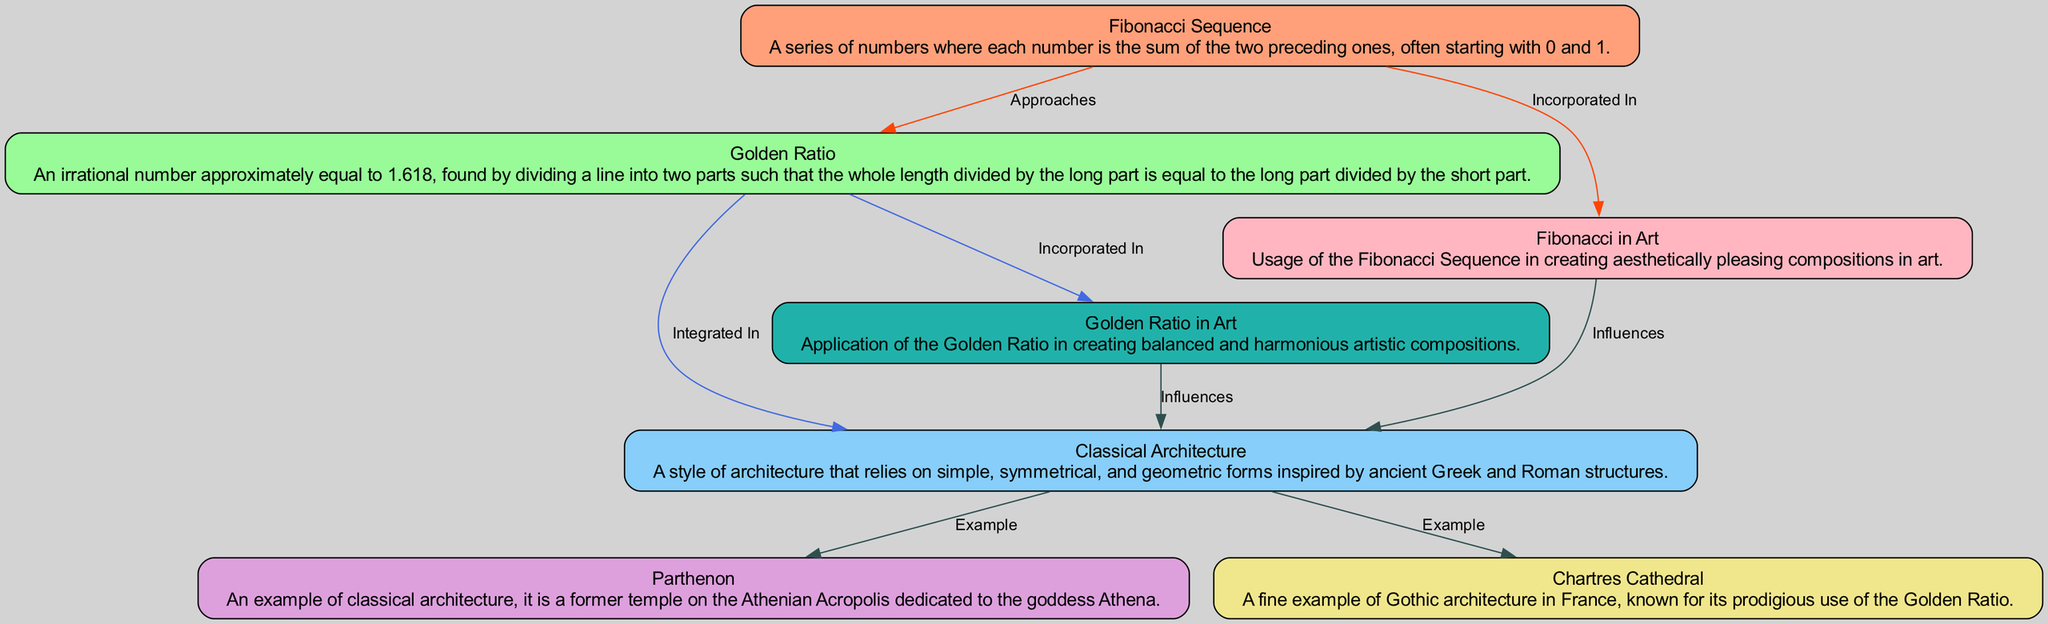What are the examples of Classical Architecture in the diagram? The diagram includes two examples of Classical Architecture: the Parthenon and Chartres Cathedral, which are highlighted as examples connecting to the Classical Architecture node.
Answer: Parthenon, Chartres Cathedral What relationship exists between the Fibonacci Sequence and the Golden Ratio? The diagram shows a directed edge labeled "Approaches" leading from the Fibonacci Sequence node to the Golden Ratio node, indicating their connection.
Answer: Approaches How many nodes are represented in the diagram? By counting the nodes listed, we can determine that there are seven unique nodes in this diagram related to Fibonacci, the Golden Ratio, and architecture.
Answer: 7 What influences the Fibonacci Sequence in this diagram? There is a directed edge labeled "Influences" connecting the Fibonacci in Art node to the Classical Architecture node, illustrating that the Fibonacci Sequence influences Classical Architecture through its application in art.
Answer: Classical Architecture What is the approximate value of the Golden Ratio? The description in the Golden Ratio node states that it is an irrational number approximately equal to 1.618, which is a key quantitative detail.
Answer: 1.618 How does the Golden Ratio relate specifically to Art in the diagram? The diagram shows a directed edge labeled "Incorporated In" leading from the Golden Ratio node to the Golden Ratio in Art node, indicating that the Golden Ratio is utilized in artistic compositions.
Answer: Incorporated In What is the connection type between the Fibonacci Sequence and Fibonacci in Art? The diagram illustrates this relationship with an edge labeled "Incorporated In," indicating that the Fibonacci Sequence is utilized in artistic compositions, linking it to the art node.
Answer: Incorporated In Which style does Classical Architecture derive from according to the diagram? The diagram delineates that Classical Architecture is inspired by ancient Greek and Roman structures, as noted in its description node.
Answer: Ancient Greek and Roman structures How many edges are present in the diagram? By counting the connections listed between nodes, we can ascertain that there are eight edges depicted in the diagram showing relationships among the nodes.
Answer: 8 